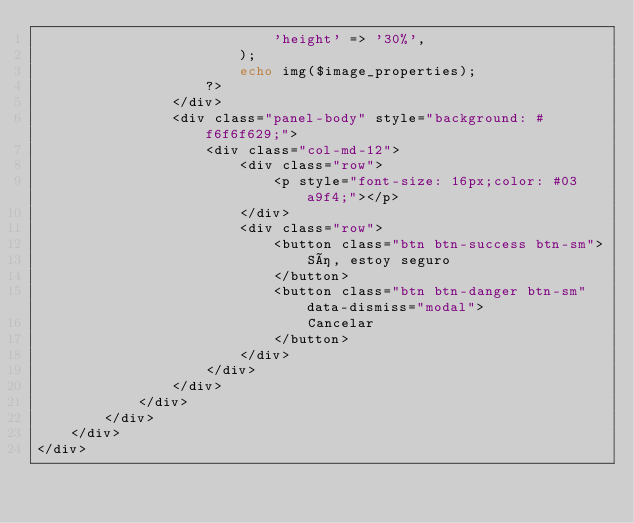Convert code to text. <code><loc_0><loc_0><loc_500><loc_500><_PHP_>                            'height' => '30%',
                        );
                        echo img($image_properties);
                    ?>
                </div>
                <div class="panel-body" style="background: #f6f6f629;">
                    <div class="col-md-12">
                        <div class="row">
                            <p style="font-size: 16px;color: #03a9f4;"></p>
                        </div>
                        <div class="row">
                            <button class="btn btn-success btn-sm">
                                Sí, estoy seguro
                            </button>
                            <button class="btn btn-danger btn-sm" data-dismiss="modal">
                                Cancelar
                            </button>
                        </div>
                    </div>
                </div>
            </div>
        </div>
    </div>
</div>


</code> 